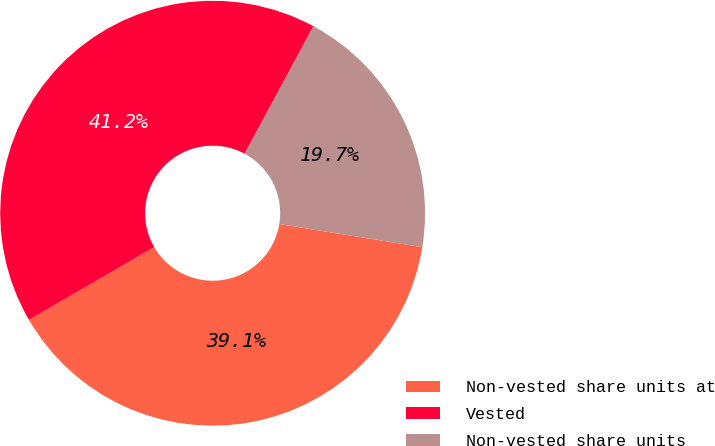Convert chart. <chart><loc_0><loc_0><loc_500><loc_500><pie_chart><fcel>Non-vested share units at<fcel>Vested<fcel>Non-vested share units<nl><fcel>39.07%<fcel>41.25%<fcel>19.69%<nl></chart> 